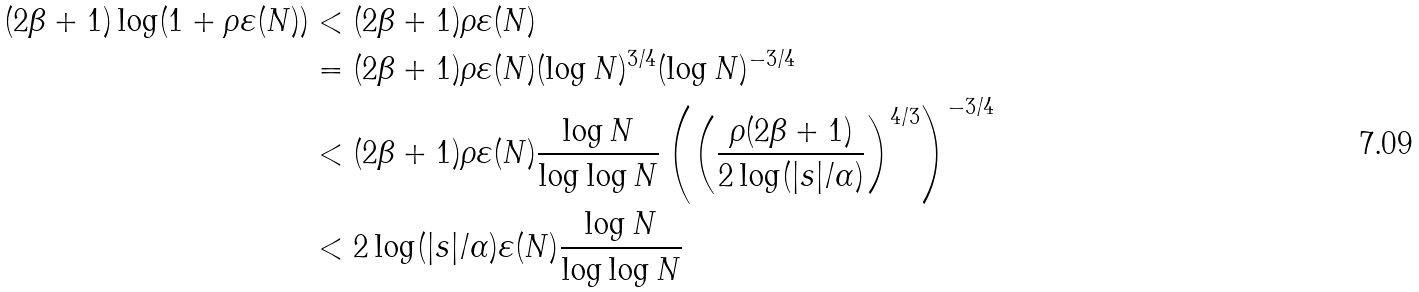Convert formula to latex. <formula><loc_0><loc_0><loc_500><loc_500>( 2 \beta + 1 ) \log ( 1 + \rho \varepsilon ( N ) ) & < ( 2 \beta + 1 ) \rho \varepsilon ( N ) \\ & = ( 2 \beta + 1 ) \rho \varepsilon ( N ) ( \log N ) ^ { 3 / 4 } ( \log N ) ^ { - 3 / 4 } \\ & < ( 2 \beta + 1 ) \rho \varepsilon ( N ) \frac { \log N } { \log \log N } \left ( \left ( \frac { \rho ( 2 \beta + 1 ) } { 2 \log ( | s | / \alpha ) } \right ) ^ { 4 / 3 } \right ) ^ { - 3 / 4 } \\ & < 2 \log ( | s | / \alpha ) \varepsilon ( N ) \frac { \log N } { \log \log N }</formula> 